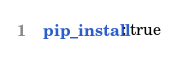<code> <loc_0><loc_0><loc_500><loc_500><_YAML_>  pip_install: true
</code> 